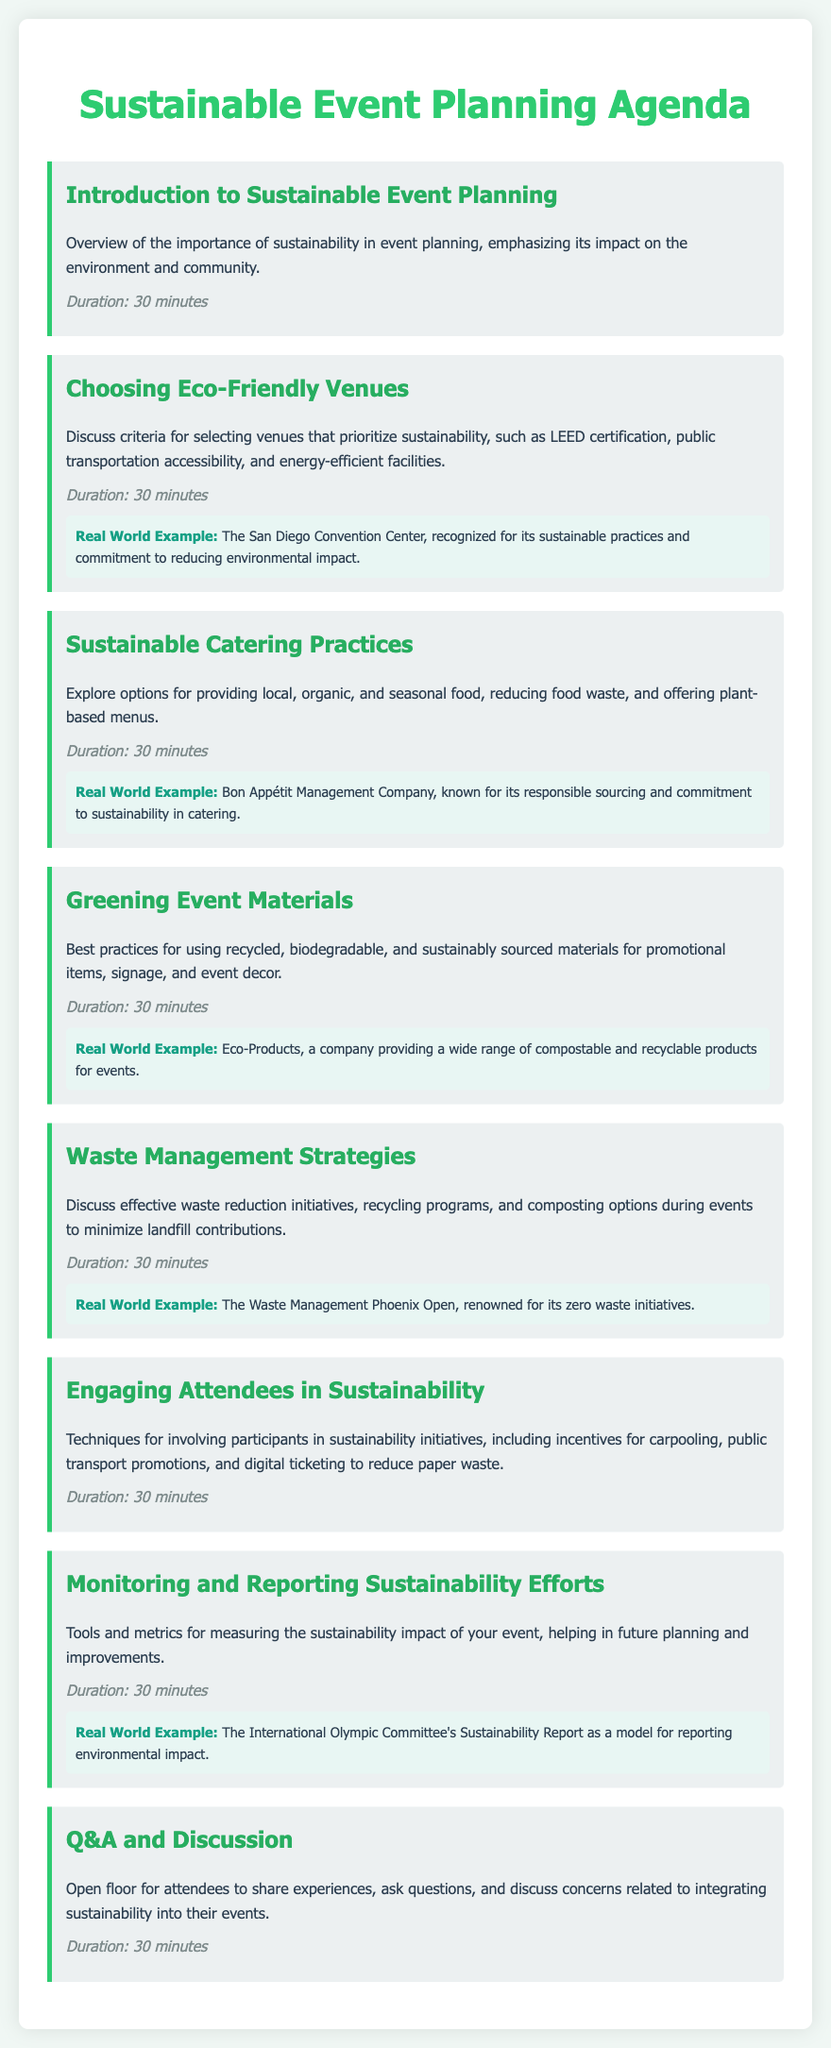What is the title of the agenda? The title is the main header of the document, which states the purpose of the content.
Answer: Sustainable Event Planning Agenda How long is the Introduction to Sustainable Event Planning session? Each agenda item specifies its duration beneath the description, which indicates how long it will last.
Answer: 30 minutes What is one criterion for choosing eco-friendly venues? The document mentions several criteria for venue selection in the related agenda item.
Answer: LEED certification Who is known for responsible sourcing in catering? The document provides a real-world example within the Sustainable Catering Practices section.
Answer: Bon Appétit Management Company What is an example of a company providing compostable products? The Greening Event Materials section includes a specific company known for its products.
Answer: Eco-Products Which event is recognized for its zero waste initiatives? The Waste Management Strategies section highlights an event with noteworthy sustainability practices.
Answer: The Waste Management Phoenix Open What is one technique to engage attendees in sustainability? The Engaging Attendees in Sustainability section suggests various methods to involve participants.
Answer: Digital ticketing What is the purpose of the Monitoring and Reporting Sustainability Efforts session? The agenda describes this session's function regarding evaluating sustainability impacts for future planning.
Answer: Measuring sustainability impact How long is the Q&A and Discussion session? Each agenda item lists its duration, including this final discussion section.
Answer: 30 minutes 